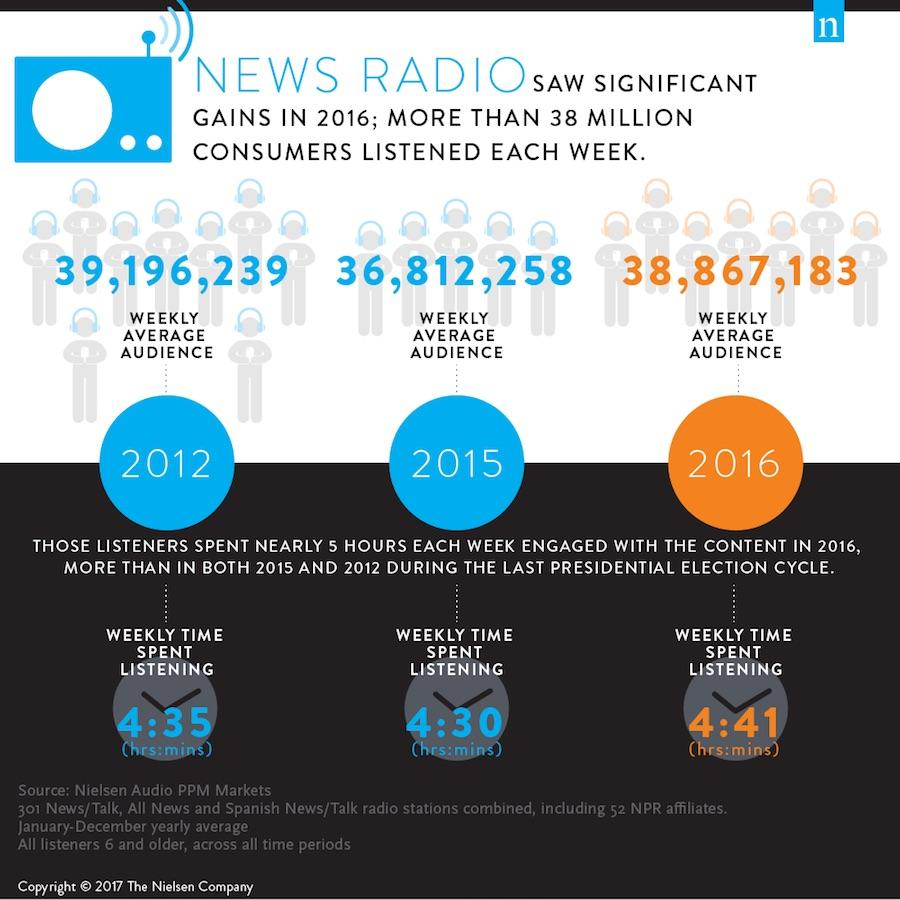Indicate a few pertinent items in this graphic. In 2015, the weakly average audience for news radio was 36,812,258. In 2016, the amount of time spent listening to news radio was 4 hours and 41 minutes. In 2012, the weakly average audience for news radio was 39,196,239 people. 